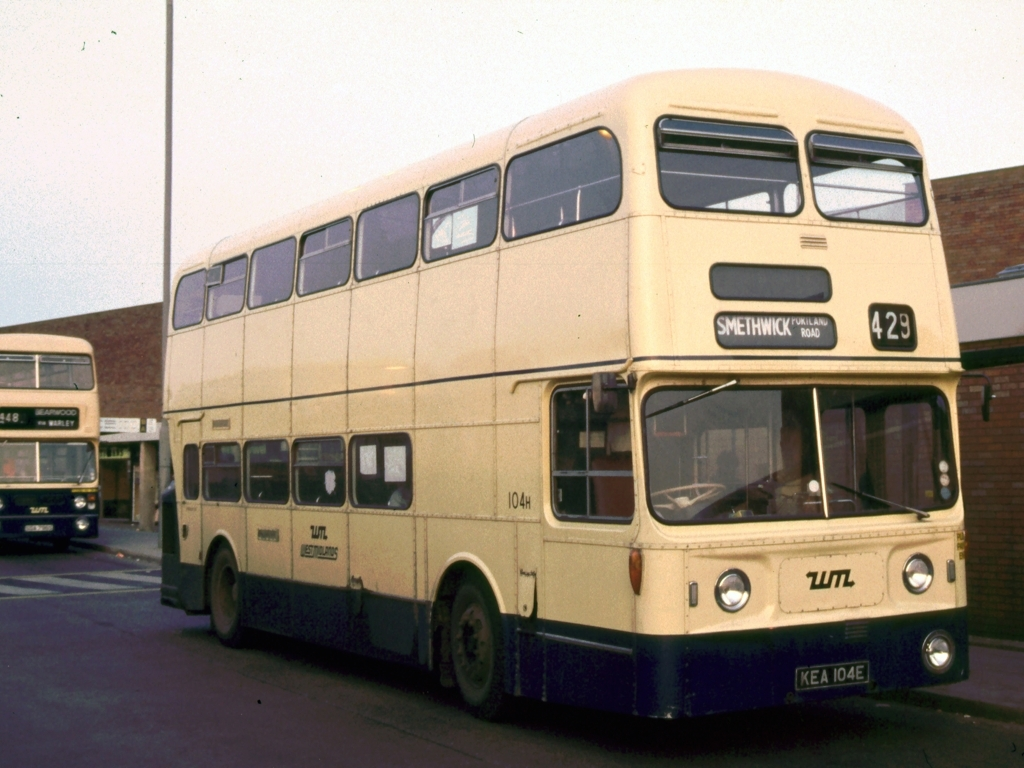Can you tell me what might be the significance of the route number displayed on the bus? The route number, 429, displayed on the bus indicates the specific path the bus would take during its service. This number helps passengers identify the bus service they require to reach their destination, in this case possibly connecting different locations such as Smethwick and West Bromwich. 